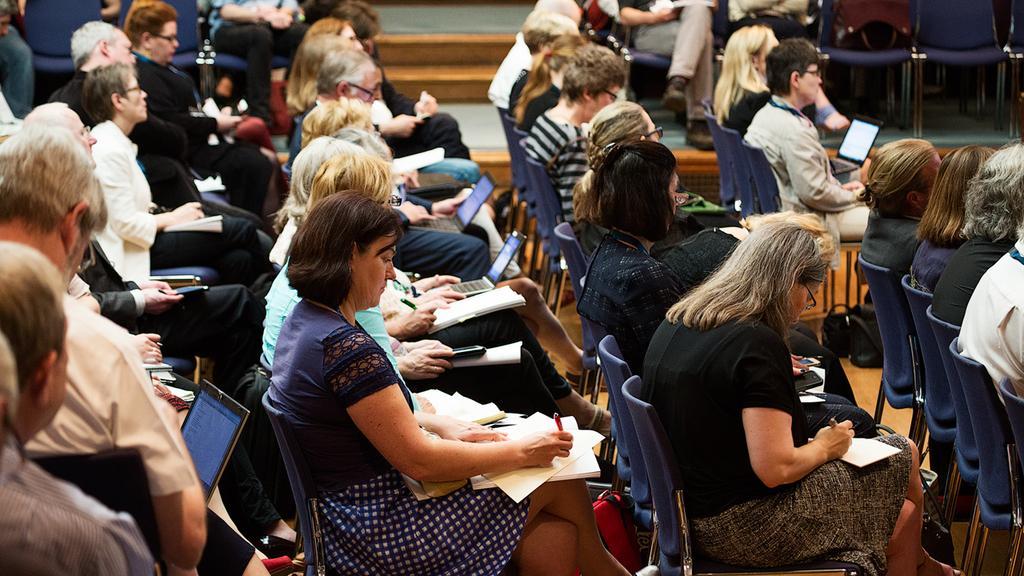Can you describe this image briefly? In this image I can see group of people sitting, they are holding few pens, papers, laptops in their hand. Background I can see chairs in blue color and few stairs. 